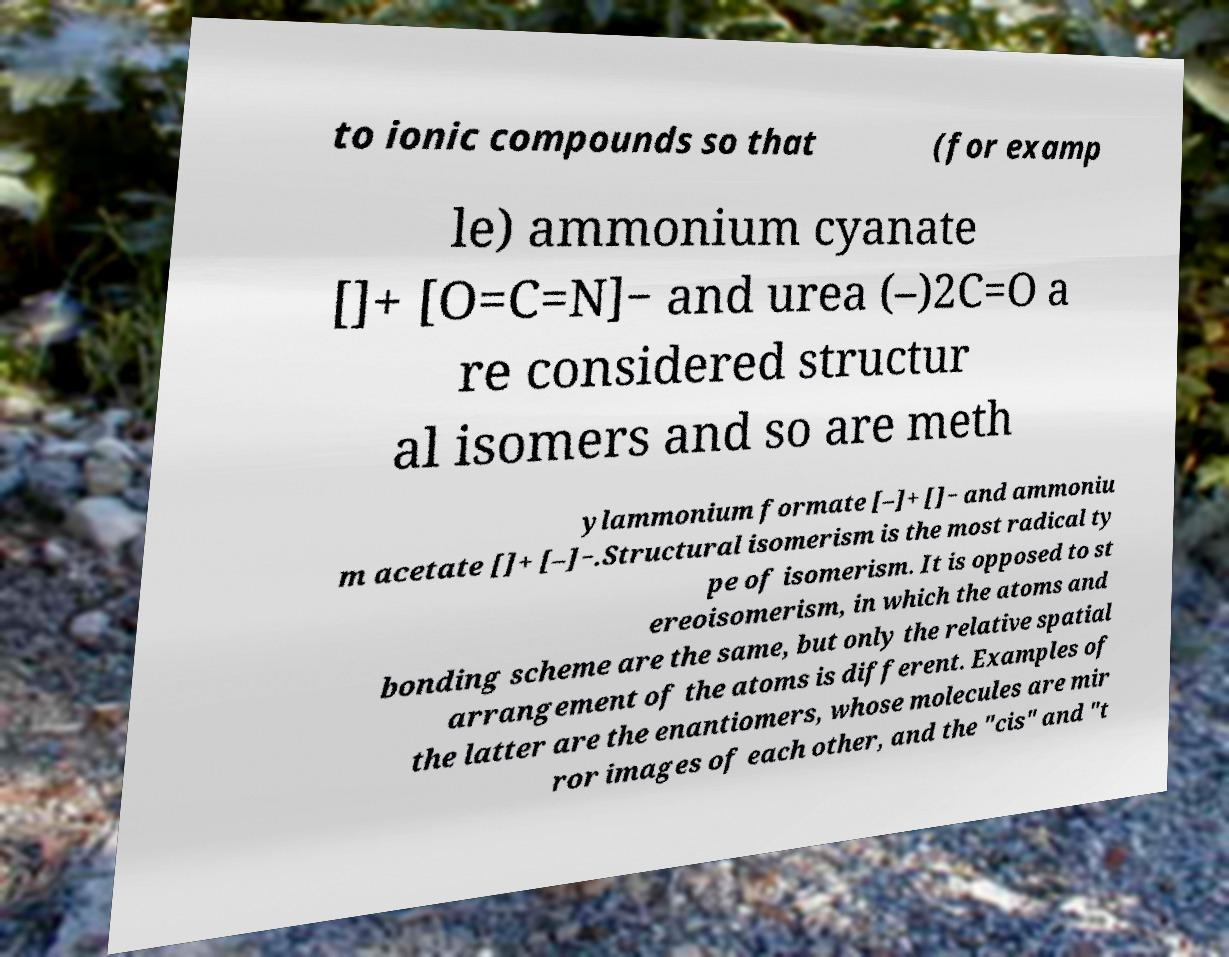Can you accurately transcribe the text from the provided image for me? to ionic compounds so that (for examp le) ammonium cyanate []+ [O=C=N]− and urea (–)2C=O a re considered structur al isomers and so are meth ylammonium formate [–]+ []− and ammoniu m acetate []+ [–]−.Structural isomerism is the most radical ty pe of isomerism. It is opposed to st ereoisomerism, in which the atoms and bonding scheme are the same, but only the relative spatial arrangement of the atoms is different. Examples of the latter are the enantiomers, whose molecules are mir ror images of each other, and the "cis" and "t 